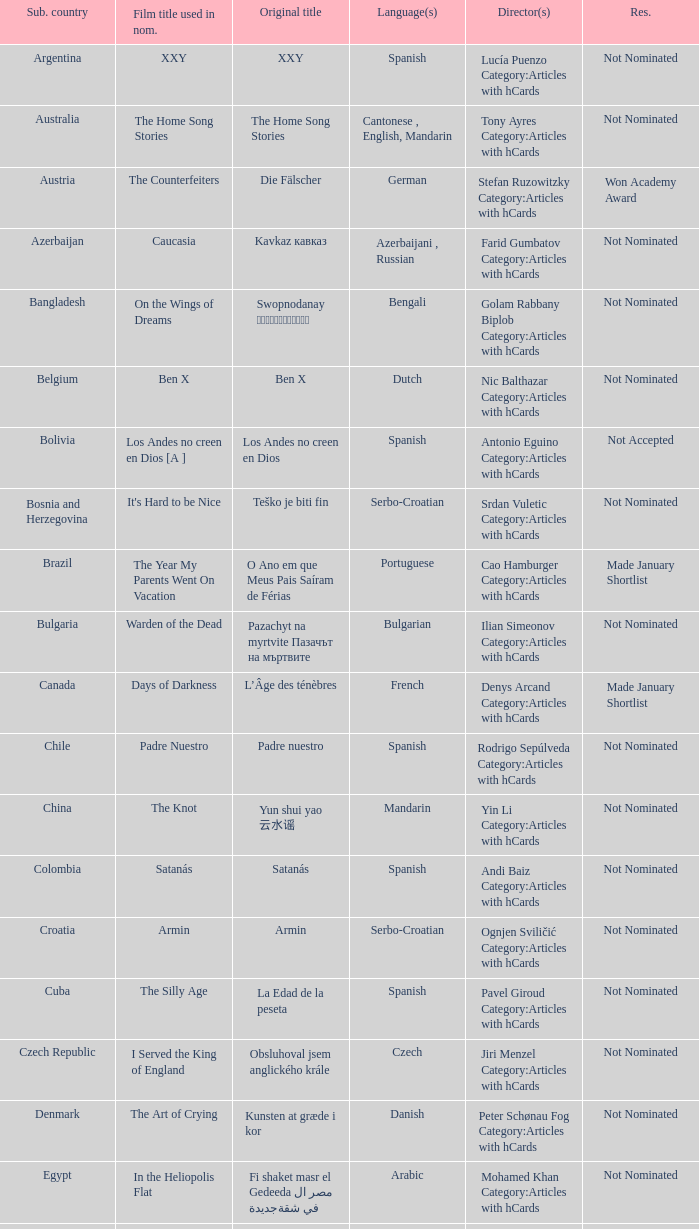What country submitted miehen työ? Finland. 